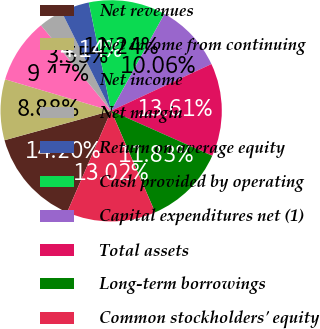Convert chart to OTSL. <chart><loc_0><loc_0><loc_500><loc_500><pie_chart><fcel>Net revenues<fcel>Net income from continuing<fcel>Net income<fcel>Net margin<fcel>Return on average equity<fcel>Cash provided by operating<fcel>Capital expenditures net (1)<fcel>Total assets<fcel>Long-term borrowings<fcel>Common stockholders' equity<nl><fcel>14.2%<fcel>8.88%<fcel>9.47%<fcel>3.55%<fcel>4.14%<fcel>11.24%<fcel>10.06%<fcel>13.61%<fcel>11.83%<fcel>13.02%<nl></chart> 